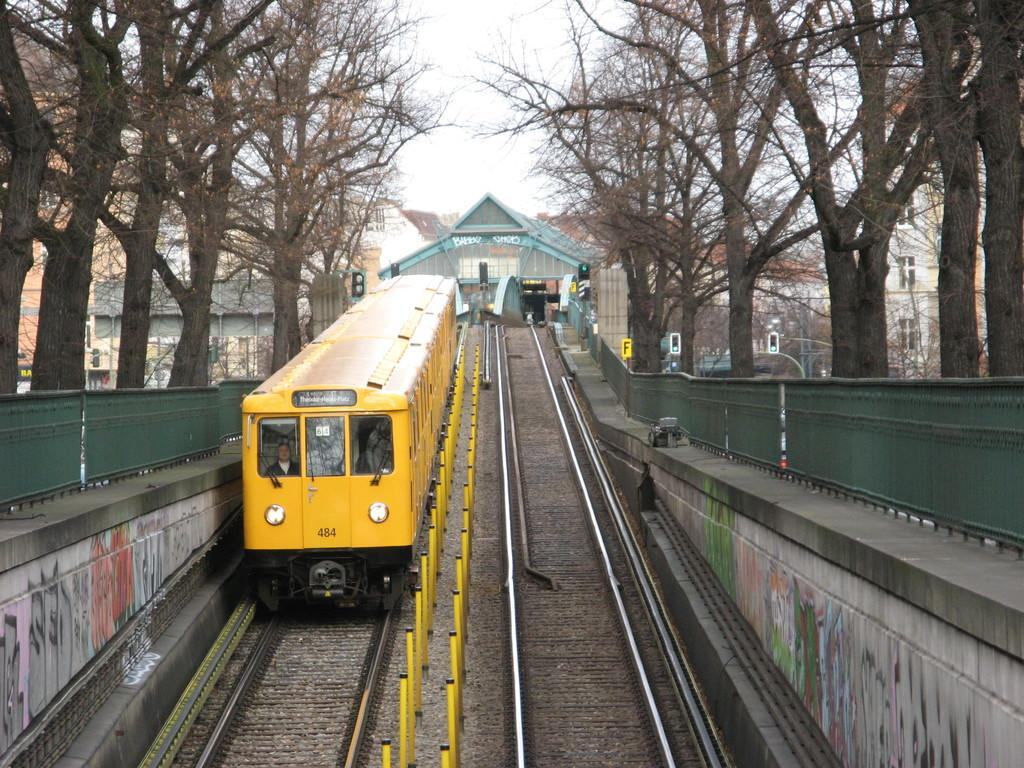What type of vehicle is in the image? There is a yellow train in the image. Where is the train located? The train is on a track. What can be seen on either side of the track? There is a fence on either side of the track. What is visible behind the train? Trees are visible behind the train. What can be seen in the background of the image? There are buildings in the background of the image. What is visible above the train? The sky is visible above the train. What type of bone can be seen in the image? There is no bone present in the image; it features a yellow train on a track with a fence, trees, buildings, and the sky visible. 